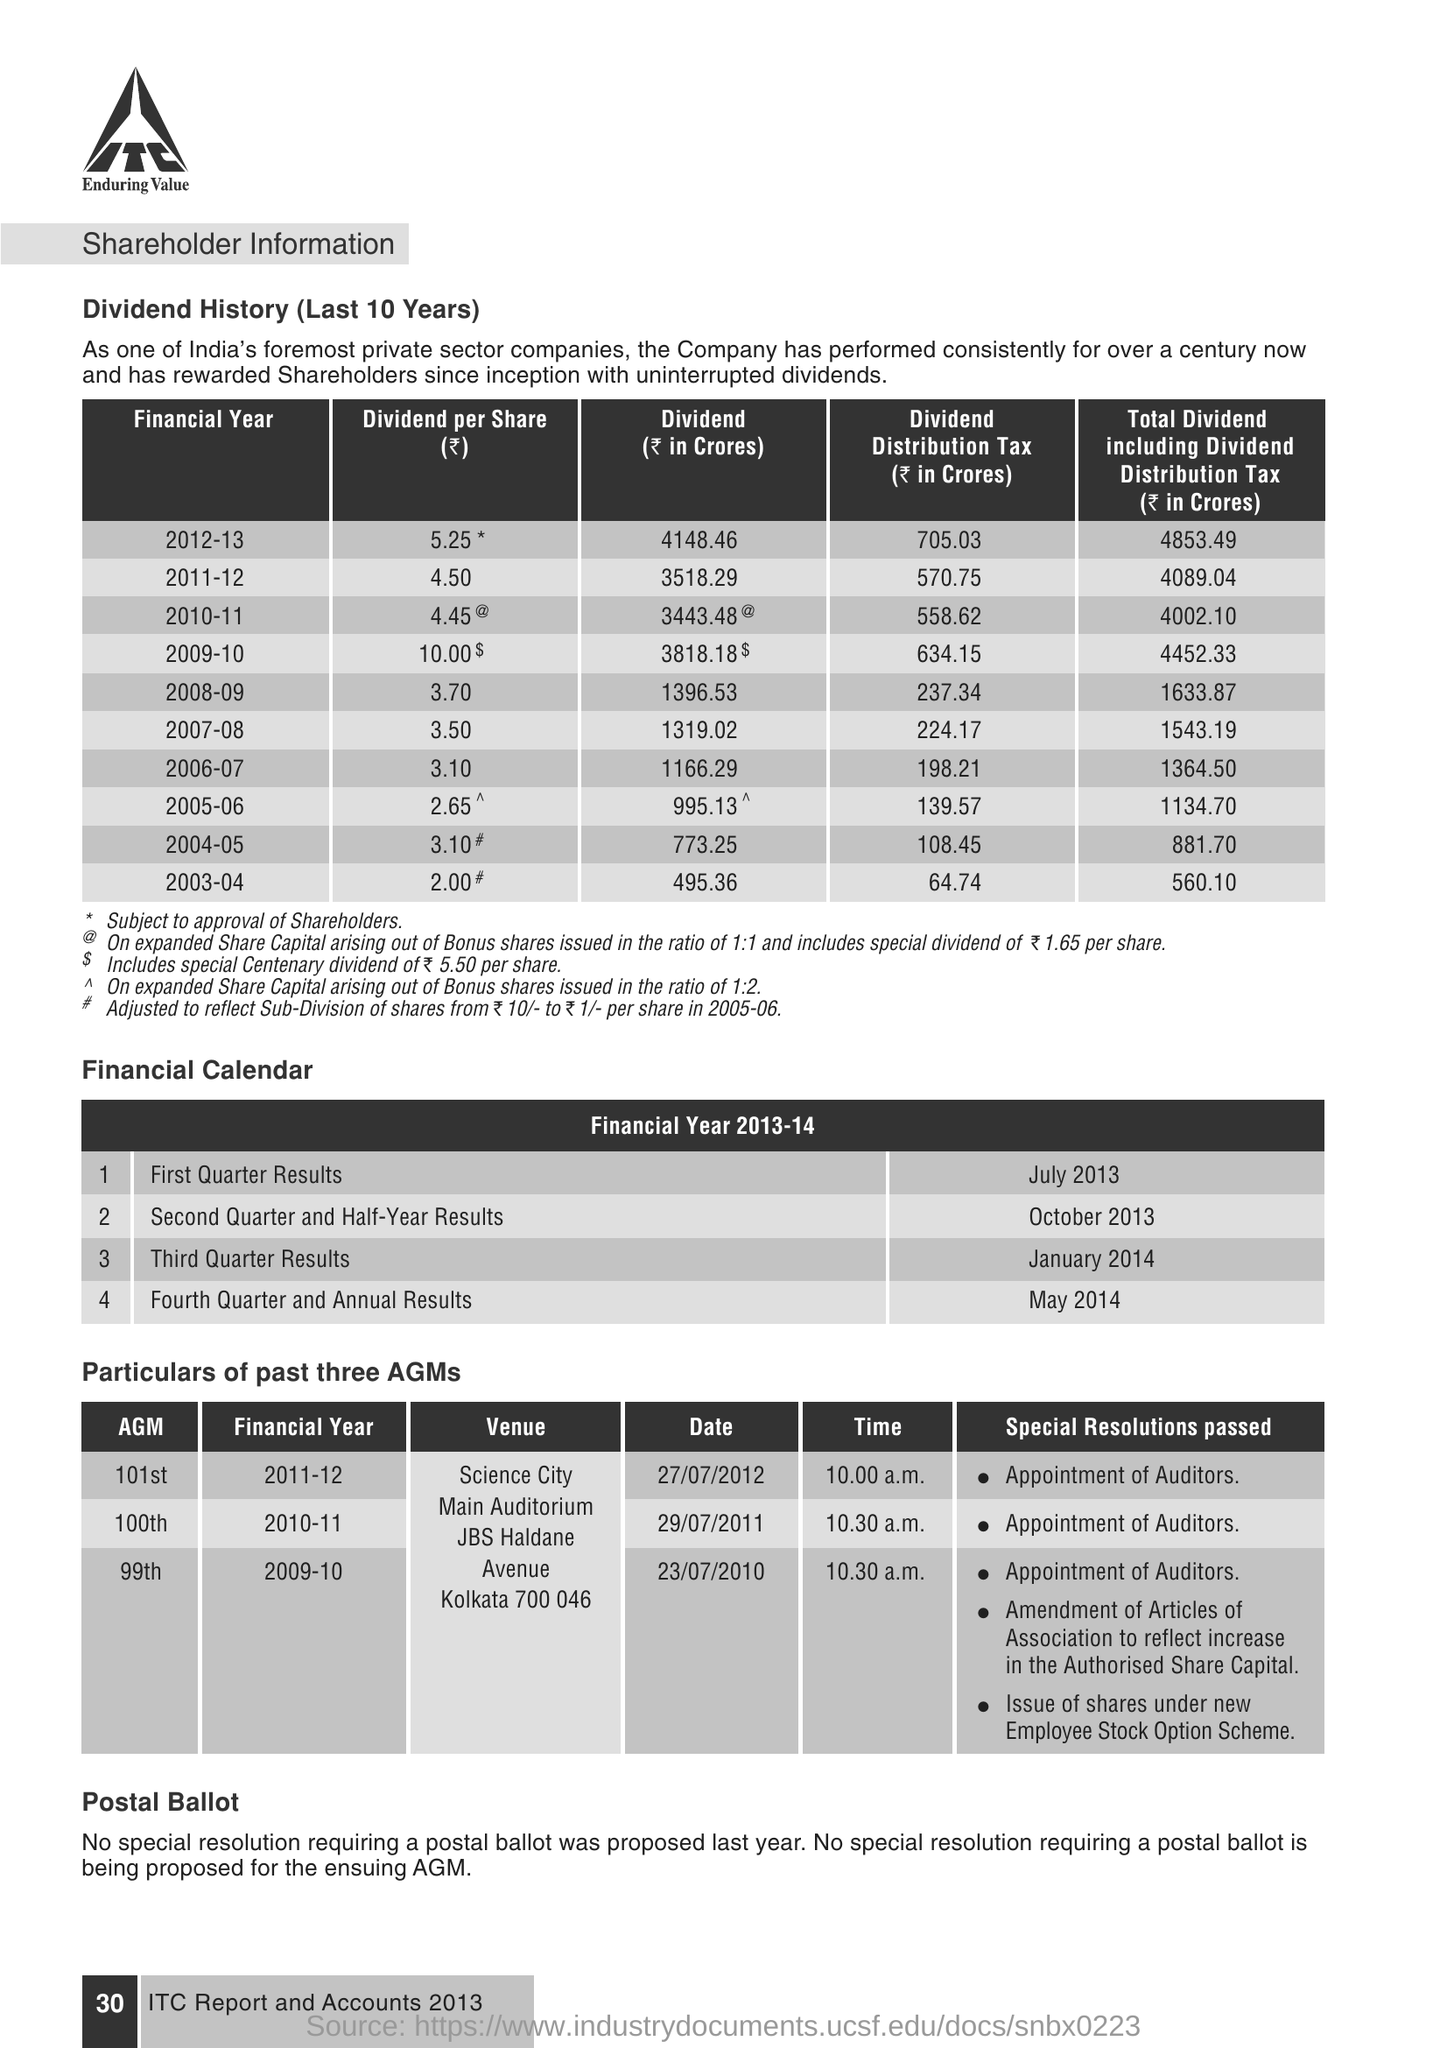What is the value of dividend per share for the financial year 2011-12 ?
Your answer should be compact. 4.50. When was the first quarter results were announced during the financial year 2013-14 ?
Offer a terse response. July 2013. When was the fourth quarter and annual results were announced during the financial year 2013-14 ?
Your response must be concise. May 2014. During which financial year 99th agm  was conducted ?
Provide a succinct answer. 2009-10. On which date the 101st agm was conducted  ?
Offer a very short reply. 27/07/2012. At what time the 100th agm was conducted ?
Provide a short and direct response. 10:30 a.m. When was the second quarter and half-year results were announced during the financial year 2013-14 ?
Offer a terse response. OCTOBER 2013. 